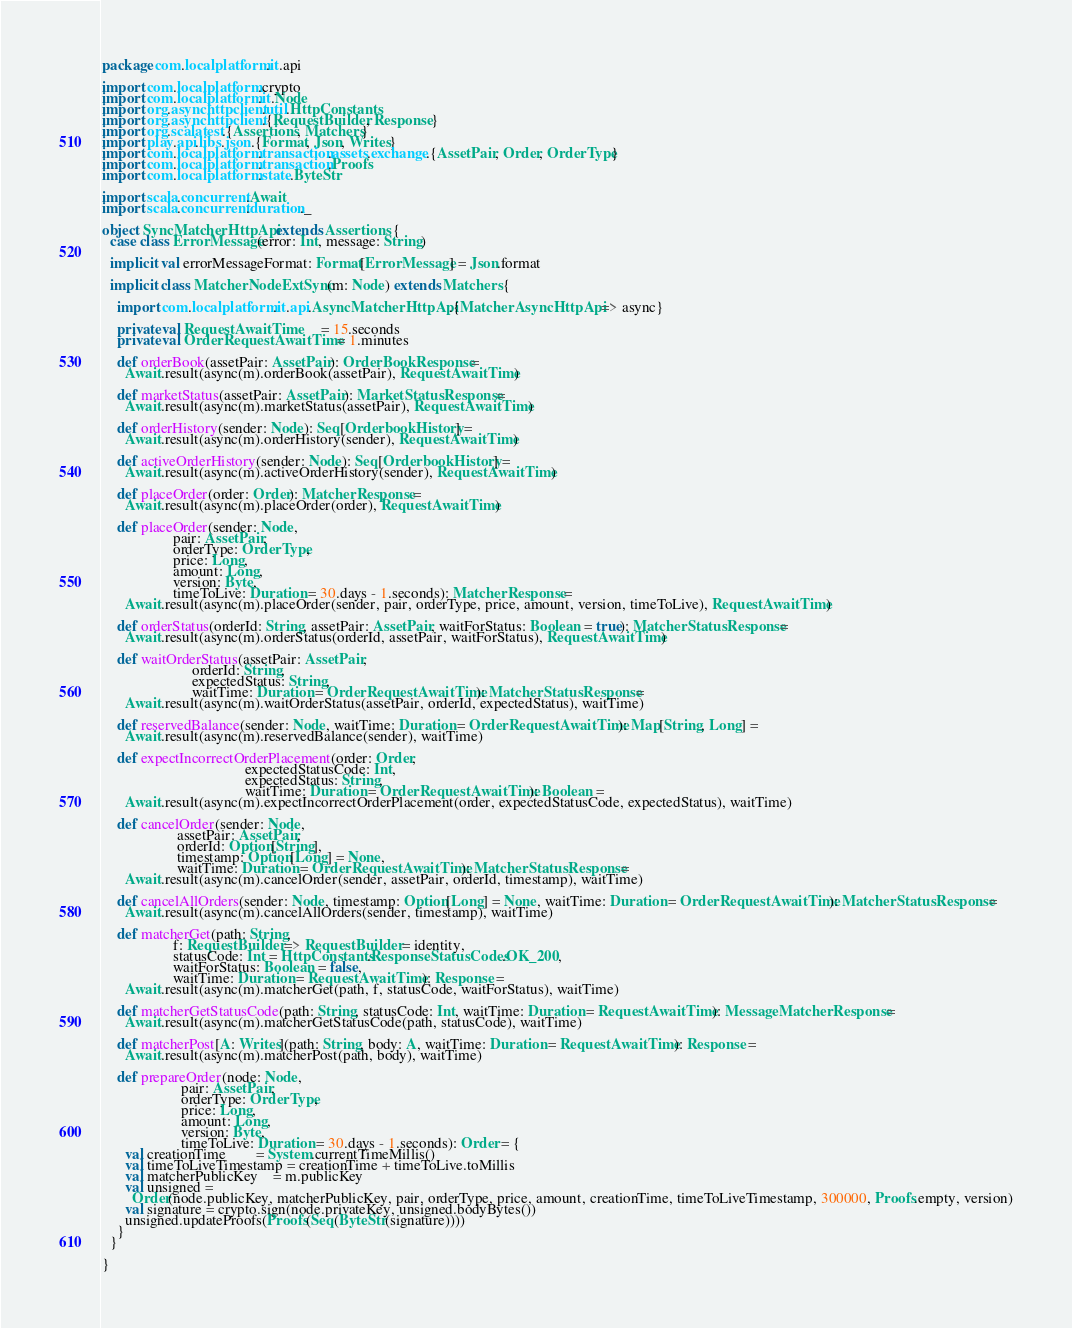<code> <loc_0><loc_0><loc_500><loc_500><_Scala_>package com.localplatform.it.api

import com.localplatform.crypto
import com.localplatform.it.Node
import org.asynchttpclient.util.HttpConstants
import org.asynchttpclient.{RequestBuilder, Response}
import org.scalatest.{Assertions, Matchers}
import play.api.libs.json.{Format, Json, Writes}
import com.localplatform.transaction.assets.exchange.{AssetPair, Order, OrderType}
import com.localplatform.transaction.Proofs
import com.localplatform.state.ByteStr

import scala.concurrent.Await
import scala.concurrent.duration._

object SyncMatcherHttpApi extends Assertions {
  case class ErrorMessage(error: Int, message: String)

  implicit val errorMessageFormat: Format[ErrorMessage] = Json.format

  implicit class MatcherNodeExtSync(m: Node) extends Matchers {

    import com.localplatform.it.api.AsyncMatcherHttpApi.{MatcherAsyncHttpApi => async}

    private val RequestAwaitTime      = 15.seconds
    private val OrderRequestAwaitTime = 1.minutes

    def orderBook(assetPair: AssetPair): OrderBookResponse =
      Await.result(async(m).orderBook(assetPair), RequestAwaitTime)

    def marketStatus(assetPair: AssetPair): MarketStatusResponse =
      Await.result(async(m).marketStatus(assetPair), RequestAwaitTime)

    def orderHistory(sender: Node): Seq[OrderbookHistory] =
      Await.result(async(m).orderHistory(sender), RequestAwaitTime)

    def activeOrderHistory(sender: Node): Seq[OrderbookHistory] =
      Await.result(async(m).activeOrderHistory(sender), RequestAwaitTime)

    def placeOrder(order: Order): MatcherResponse =
      Await.result(async(m).placeOrder(order), RequestAwaitTime)

    def placeOrder(sender: Node,
                   pair: AssetPair,
                   orderType: OrderType,
                   price: Long,
                   amount: Long,
                   version: Byte,
                   timeToLive: Duration = 30.days - 1.seconds): MatcherResponse =
      Await.result(async(m).placeOrder(sender, pair, orderType, price, amount, version, timeToLive), RequestAwaitTime)

    def orderStatus(orderId: String, assetPair: AssetPair, waitForStatus: Boolean = true): MatcherStatusResponse =
      Await.result(async(m).orderStatus(orderId, assetPair, waitForStatus), RequestAwaitTime)

    def waitOrderStatus(assetPair: AssetPair,
                        orderId: String,
                        expectedStatus: String,
                        waitTime: Duration = OrderRequestAwaitTime): MatcherStatusResponse =
      Await.result(async(m).waitOrderStatus(assetPair, orderId, expectedStatus), waitTime)

    def reservedBalance(sender: Node, waitTime: Duration = OrderRequestAwaitTime): Map[String, Long] =
      Await.result(async(m).reservedBalance(sender), waitTime)

    def expectIncorrectOrderPlacement(order: Order,
                                      expectedStatusCode: Int,
                                      expectedStatus: String,
                                      waitTime: Duration = OrderRequestAwaitTime): Boolean =
      Await.result(async(m).expectIncorrectOrderPlacement(order, expectedStatusCode, expectedStatus), waitTime)

    def cancelOrder(sender: Node,
                    assetPair: AssetPair,
                    orderId: Option[String],
                    timestamp: Option[Long] = None,
                    waitTime: Duration = OrderRequestAwaitTime): MatcherStatusResponse =
      Await.result(async(m).cancelOrder(sender, assetPair, orderId, timestamp), waitTime)

    def cancelAllOrders(sender: Node, timestamp: Option[Long] = None, waitTime: Duration = OrderRequestAwaitTime): MatcherStatusResponse =
      Await.result(async(m).cancelAllOrders(sender, timestamp), waitTime)

    def matcherGet(path: String,
                   f: RequestBuilder => RequestBuilder = identity,
                   statusCode: Int = HttpConstants.ResponseStatusCodes.OK_200,
                   waitForStatus: Boolean = false,
                   waitTime: Duration = RequestAwaitTime): Response =
      Await.result(async(m).matcherGet(path, f, statusCode, waitForStatus), waitTime)

    def matcherGetStatusCode(path: String, statusCode: Int, waitTime: Duration = RequestAwaitTime): MessageMatcherResponse =
      Await.result(async(m).matcherGetStatusCode(path, statusCode), waitTime)

    def matcherPost[A: Writes](path: String, body: A, waitTime: Duration = RequestAwaitTime): Response =
      Await.result(async(m).matcherPost(path, body), waitTime)

    def prepareOrder(node: Node,
                     pair: AssetPair,
                     orderType: OrderType,
                     price: Long,
                     amount: Long,
                     version: Byte,
                     timeToLive: Duration = 30.days - 1.seconds): Order = {
      val creationTime        = System.currentTimeMillis()
      val timeToLiveTimestamp = creationTime + timeToLive.toMillis
      val matcherPublicKey    = m.publicKey
      val unsigned =
        Order(node.publicKey, matcherPublicKey, pair, orderType, price, amount, creationTime, timeToLiveTimestamp, 300000, Proofs.empty, version)
      val signature = crypto.sign(node.privateKey, unsigned.bodyBytes())
      unsigned.updateProofs(Proofs(Seq(ByteStr(signature))))
    }
  }

}
</code> 